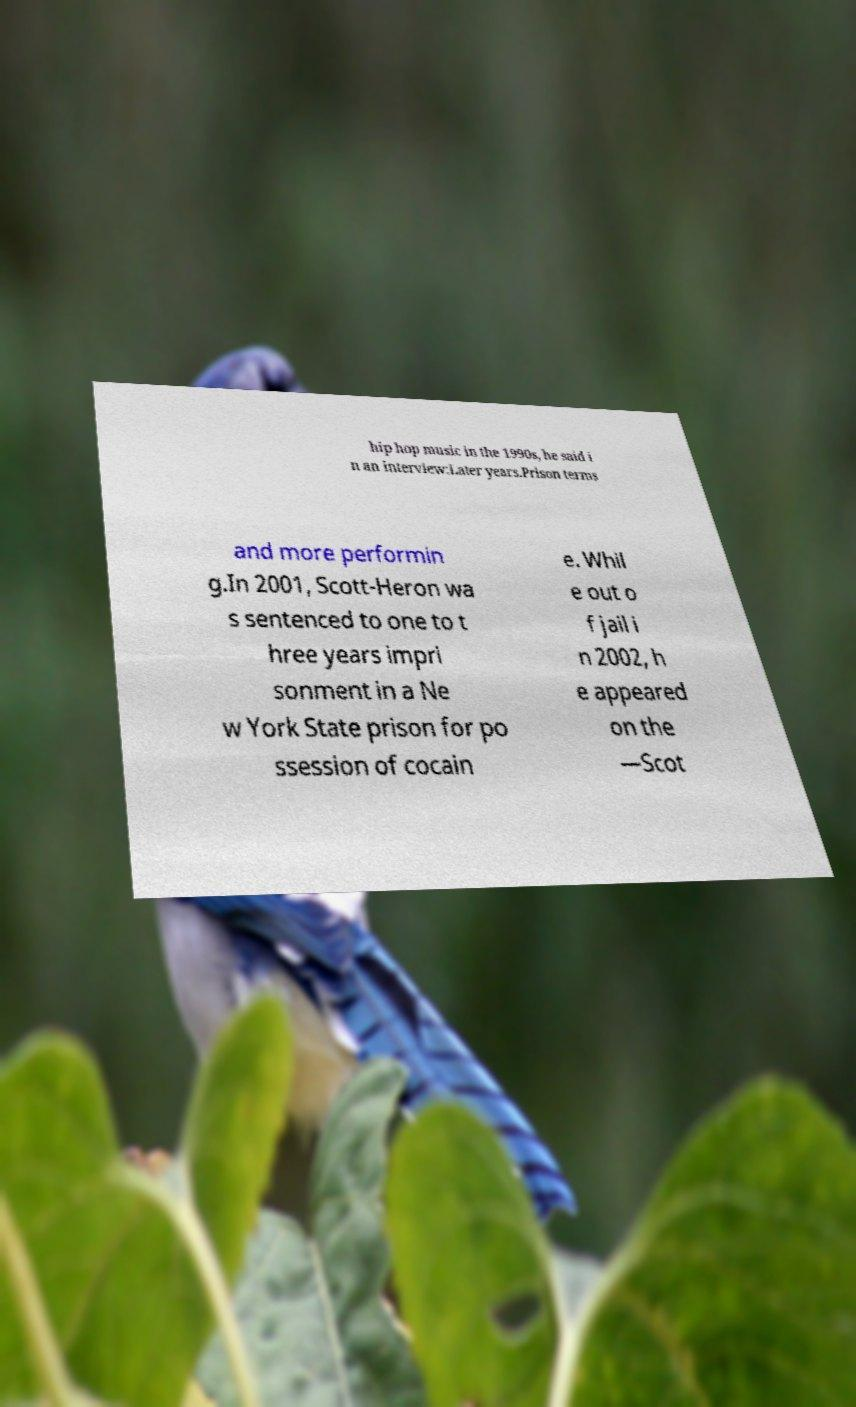Please read and relay the text visible in this image. What does it say? hip hop music in the 1990s, he said i n an interview:Later years.Prison terms and more performin g.In 2001, Scott-Heron wa s sentenced to one to t hree years impri sonment in a Ne w York State prison for po ssession of cocain e. Whil e out o f jail i n 2002, h e appeared on the —Scot 